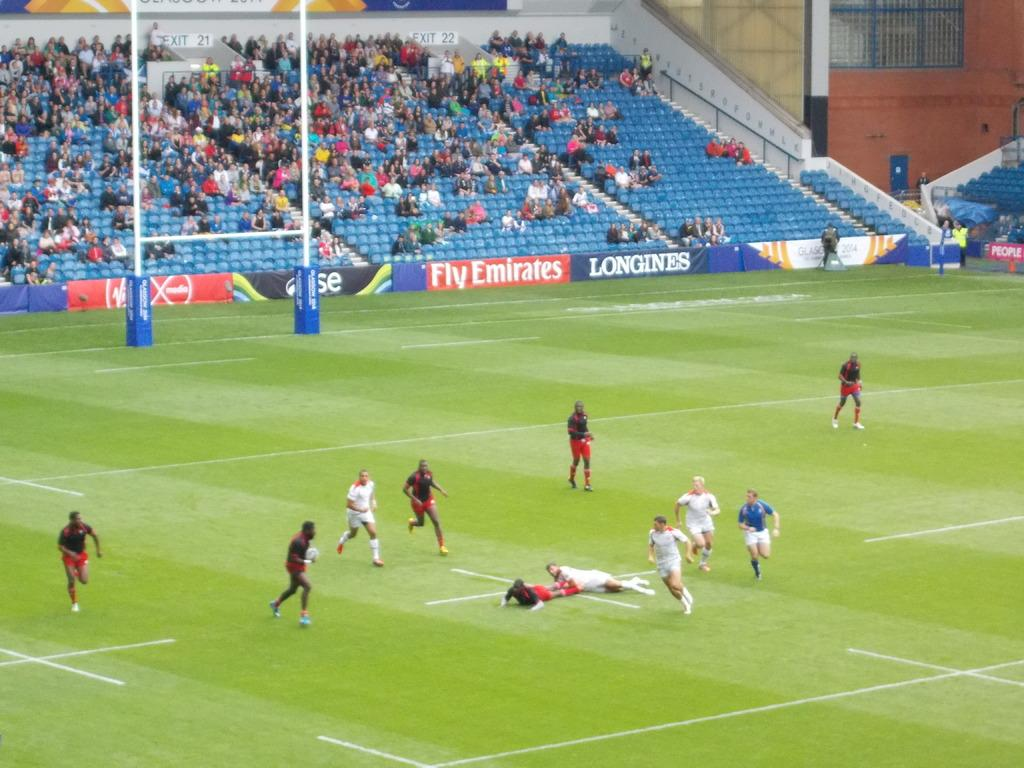<image>
Offer a succinct explanation of the picture presented. A soccer match finds two players down on the field, and a "Fly Emirates" banner in the background. 